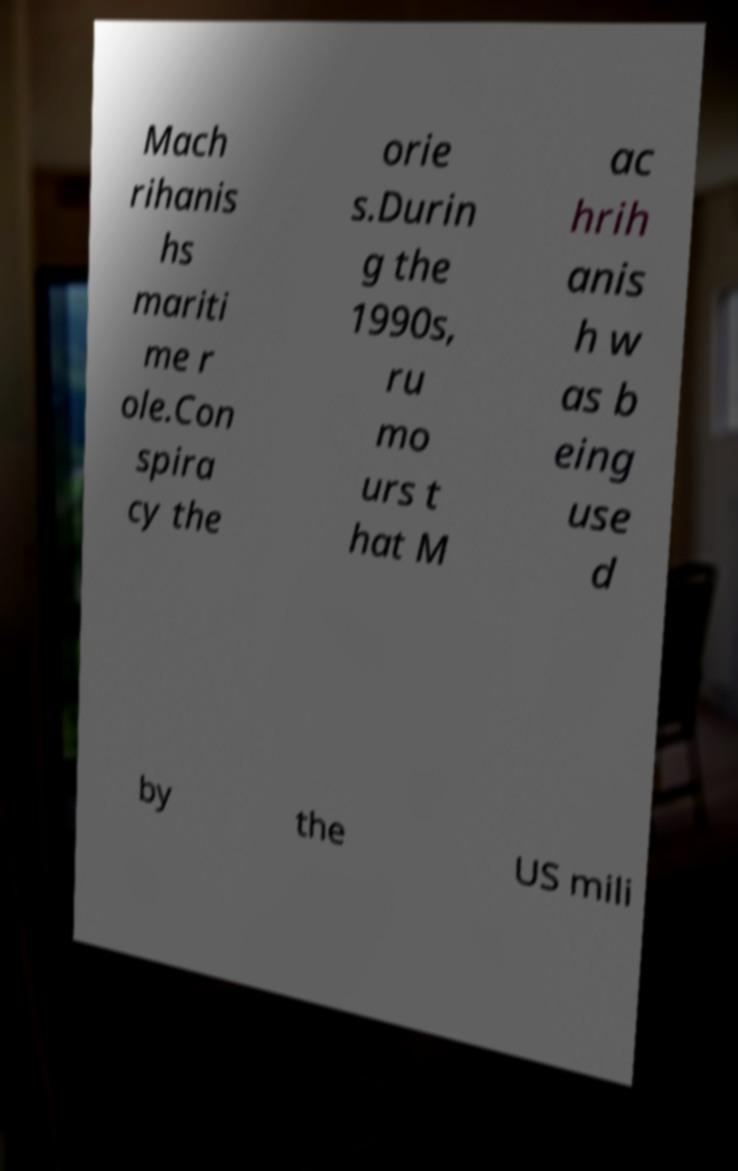Can you accurately transcribe the text from the provided image for me? Mach rihanis hs mariti me r ole.Con spira cy the orie s.Durin g the 1990s, ru mo urs t hat M ac hrih anis h w as b eing use d by the US mili 